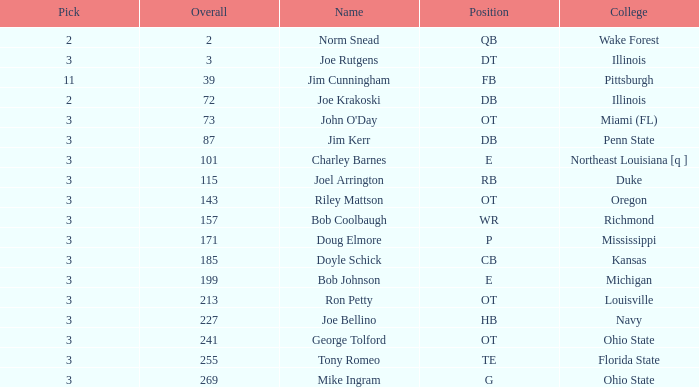How many rounds have john o'day as the name, and a pick less than 3? None. 